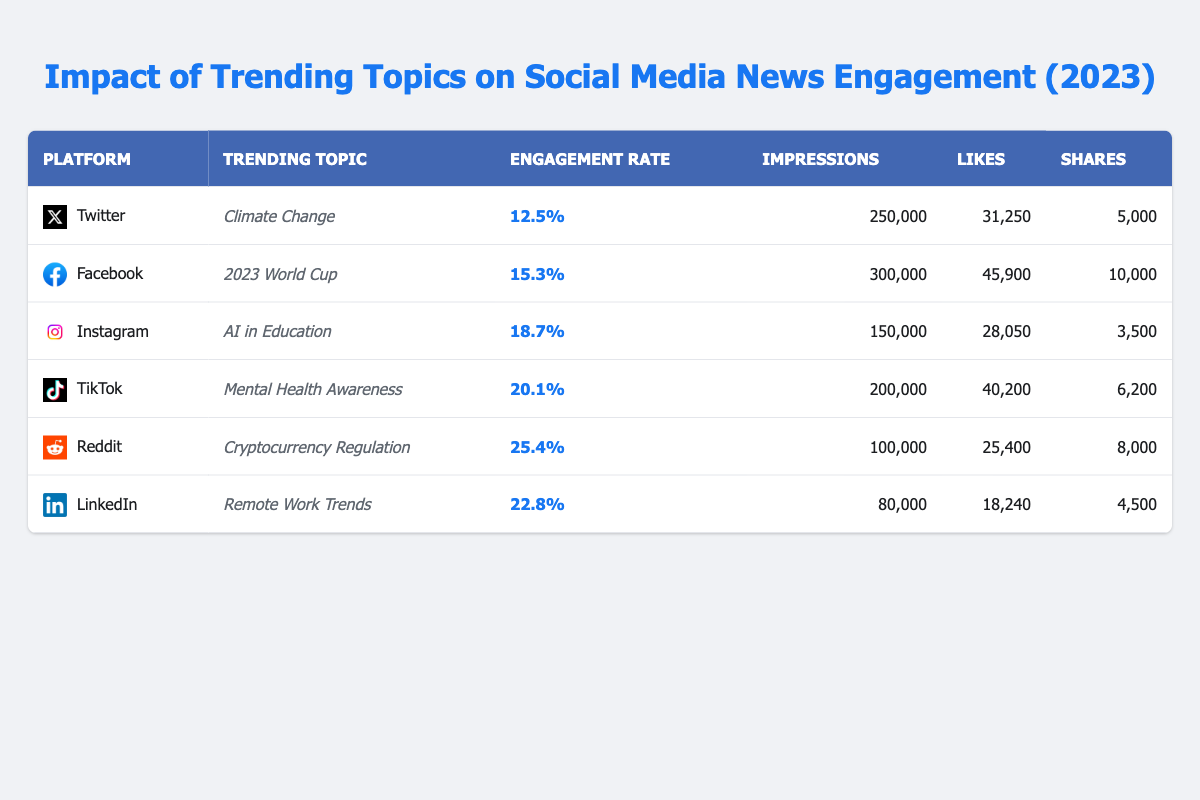What is the engagement rate for the trending topic "Cryptocurrency Regulation" on Reddit? The table lists the engagement rate for each trending topic on different platforms. For Reddit and the topic "Cryptocurrency Regulation," the engagement rate is shown as **25.4%**.
Answer: 25.4% Which platform had the highest engagement rate among the listed topics? By comparing the engagement rates across all platforms in the table, TikTok has the highest rate at **20.1%**, while Reddit follows closely with **25.4%**, making it the highest overall.
Answer: Reddit Calculate the total number of impressions across all platforms. The impressions for each platform listed in the table are **250,000** (Twitter), **300,000** (Facebook), **150,000** (Instagram), **200,000** (TikTok), **100,000** (Reddit), and **80,000** (LinkedIn). Summing these values gives **1,080,000** impressions (250,000 + 300,000 + 150,000 + 200,000 + 100,000 + 80,000 = 1,080,000).
Answer: 1,080,000 Is the engagement rate for "AI in Education" on Instagram higher or lower than that for "Mental Health Awareness" on TikTok? The engagement rate for "AI in Education" on Instagram is **18.7%**, while "Mental Health Awareness" on TikTok is **20.1%**. Comparing these rates, TikTok has a higher engagement rate than Instagram, hence it's lower on Instagram.
Answer: Lower What is the average engagement rate for the six platforms listed in the table? The engagement rates are **12.5%** (Twitter), **15.3%** (Facebook), **18.7%** (Instagram), **20.1%** (TikTok), **25.4%** (Reddit), and **22.8%** (LinkedIn). Adding these gives **114.8%**. Dividing by the number of platforms (6) provides an average engagement rate of **19.13%** (114.8% / 6 = 19.13%).
Answer: 19.13% Which trending topic on Facebook has the most shares? The shares for the trending topic "2023 World Cup" on Facebook are listed as **10,000**, which is higher than the shares for other trending topics from different platforms, making it the most shared topic.
Answer: 10,000 How much higher is the engagement rate for "Remote Work Trends" on LinkedIn than that for "Climate Change" on Twitter? The engagement rate for "Remote Work Trends" on LinkedIn is **22.8%**, and for "Climate Change" on Twitter is **12.5%**. The difference in engagement rates is calculated as **22.8% - 12.5% = 10.3%**, indicating LinkedIn's engagement rate is higher by that amount.
Answer: 10.3% Which platform had the lowest number of likes and what was that number? By examining the likes across all platforms, Reddit shows the lowest number at **25,400** likes for the topic "Cryptocurrency Regulation," making it the platform with the least likes.
Answer: 25,400 What is the total number of shares for the trending topics listed on Instagram, TikTok, and Reddit combined? The shares for Instagram ("AI in Education") is **3,500**, for TikTok ("Mental Health Awareness") is **6,200**, and for Reddit ("Cryptocurrency Regulation") is **8,000**. Adding these gives a total of **17,700** shares (3,500 + 6,200 + 8,000 = 17,700).
Answer: 17,700 